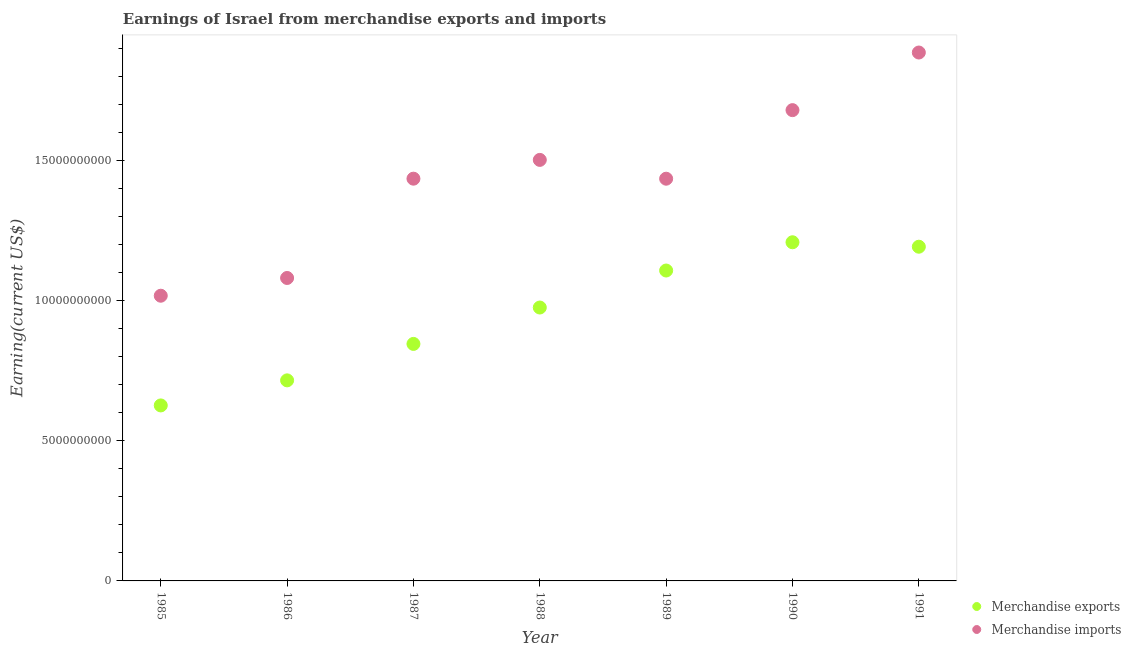What is the earnings from merchandise imports in 1986?
Keep it short and to the point. 1.08e+1. Across all years, what is the maximum earnings from merchandise exports?
Your answer should be very brief. 1.21e+1. Across all years, what is the minimum earnings from merchandise imports?
Provide a short and direct response. 1.02e+1. In which year was the earnings from merchandise imports maximum?
Your answer should be compact. 1991. In which year was the earnings from merchandise imports minimum?
Offer a very short reply. 1985. What is the total earnings from merchandise exports in the graph?
Offer a terse response. 6.67e+1. What is the difference between the earnings from merchandise imports in 1990 and that in 1991?
Your response must be concise. -2.06e+09. What is the difference between the earnings from merchandise imports in 1987 and the earnings from merchandise exports in 1990?
Make the answer very short. 2.27e+09. What is the average earnings from merchandise imports per year?
Keep it short and to the point. 1.43e+1. In the year 1990, what is the difference between the earnings from merchandise exports and earnings from merchandise imports?
Offer a terse response. -4.71e+09. In how many years, is the earnings from merchandise imports greater than 18000000000 US$?
Give a very brief answer. 1. What is the ratio of the earnings from merchandise imports in 1990 to that in 1991?
Your response must be concise. 0.89. What is the difference between the highest and the second highest earnings from merchandise imports?
Your answer should be compact. 2.06e+09. What is the difference between the highest and the lowest earnings from merchandise imports?
Ensure brevity in your answer.  8.68e+09. In how many years, is the earnings from merchandise exports greater than the average earnings from merchandise exports taken over all years?
Offer a very short reply. 4. Is the earnings from merchandise imports strictly greater than the earnings from merchandise exports over the years?
Offer a very short reply. Yes. Are the values on the major ticks of Y-axis written in scientific E-notation?
Ensure brevity in your answer.  No. How many legend labels are there?
Give a very brief answer. 2. How are the legend labels stacked?
Make the answer very short. Vertical. What is the title of the graph?
Keep it short and to the point. Earnings of Israel from merchandise exports and imports. Does "GDP per capita" appear as one of the legend labels in the graph?
Offer a very short reply. No. What is the label or title of the X-axis?
Provide a short and direct response. Year. What is the label or title of the Y-axis?
Give a very brief answer. Earning(current US$). What is the Earning(current US$) of Merchandise exports in 1985?
Offer a very short reply. 6.26e+09. What is the Earning(current US$) in Merchandise imports in 1985?
Your response must be concise. 1.02e+1. What is the Earning(current US$) of Merchandise exports in 1986?
Your response must be concise. 7.15e+09. What is the Earning(current US$) of Merchandise imports in 1986?
Your answer should be very brief. 1.08e+1. What is the Earning(current US$) in Merchandise exports in 1987?
Keep it short and to the point. 8.45e+09. What is the Earning(current US$) of Merchandise imports in 1987?
Provide a succinct answer. 1.43e+1. What is the Earning(current US$) in Merchandise exports in 1988?
Your response must be concise. 9.75e+09. What is the Earning(current US$) in Merchandise imports in 1988?
Provide a short and direct response. 1.50e+1. What is the Earning(current US$) of Merchandise exports in 1989?
Give a very brief answer. 1.11e+1. What is the Earning(current US$) in Merchandise imports in 1989?
Your answer should be compact. 1.43e+1. What is the Earning(current US$) of Merchandise exports in 1990?
Offer a terse response. 1.21e+1. What is the Earning(current US$) of Merchandise imports in 1990?
Give a very brief answer. 1.68e+1. What is the Earning(current US$) of Merchandise exports in 1991?
Make the answer very short. 1.19e+1. What is the Earning(current US$) in Merchandise imports in 1991?
Your answer should be compact. 1.88e+1. Across all years, what is the maximum Earning(current US$) of Merchandise exports?
Make the answer very short. 1.21e+1. Across all years, what is the maximum Earning(current US$) in Merchandise imports?
Your response must be concise. 1.88e+1. Across all years, what is the minimum Earning(current US$) of Merchandise exports?
Provide a succinct answer. 6.26e+09. Across all years, what is the minimum Earning(current US$) in Merchandise imports?
Offer a very short reply. 1.02e+1. What is the total Earning(current US$) in Merchandise exports in the graph?
Your response must be concise. 6.67e+1. What is the total Earning(current US$) in Merchandise imports in the graph?
Give a very brief answer. 1.00e+11. What is the difference between the Earning(current US$) in Merchandise exports in 1985 and that in 1986?
Provide a short and direct response. -8.94e+08. What is the difference between the Earning(current US$) in Merchandise imports in 1985 and that in 1986?
Ensure brevity in your answer.  -6.33e+08. What is the difference between the Earning(current US$) in Merchandise exports in 1985 and that in 1987?
Offer a very short reply. -2.19e+09. What is the difference between the Earning(current US$) in Merchandise imports in 1985 and that in 1987?
Offer a very short reply. -4.18e+09. What is the difference between the Earning(current US$) of Merchandise exports in 1985 and that in 1988?
Your response must be concise. -3.49e+09. What is the difference between the Earning(current US$) of Merchandise imports in 1985 and that in 1988?
Provide a short and direct response. -4.84e+09. What is the difference between the Earning(current US$) in Merchandise exports in 1985 and that in 1989?
Offer a very short reply. -4.81e+09. What is the difference between the Earning(current US$) in Merchandise imports in 1985 and that in 1989?
Your answer should be compact. -4.17e+09. What is the difference between the Earning(current US$) of Merchandise exports in 1985 and that in 1990?
Give a very brief answer. -5.82e+09. What is the difference between the Earning(current US$) of Merchandise imports in 1985 and that in 1990?
Offer a very short reply. -6.62e+09. What is the difference between the Earning(current US$) of Merchandise exports in 1985 and that in 1991?
Your response must be concise. -5.66e+09. What is the difference between the Earning(current US$) of Merchandise imports in 1985 and that in 1991?
Keep it short and to the point. -8.68e+09. What is the difference between the Earning(current US$) of Merchandise exports in 1986 and that in 1987?
Your answer should be very brief. -1.30e+09. What is the difference between the Earning(current US$) of Merchandise imports in 1986 and that in 1987?
Ensure brevity in your answer.  -3.54e+09. What is the difference between the Earning(current US$) in Merchandise exports in 1986 and that in 1988?
Make the answer very short. -2.60e+09. What is the difference between the Earning(current US$) of Merchandise imports in 1986 and that in 1988?
Provide a succinct answer. -4.21e+09. What is the difference between the Earning(current US$) of Merchandise exports in 1986 and that in 1989?
Keep it short and to the point. -3.92e+09. What is the difference between the Earning(current US$) in Merchandise imports in 1986 and that in 1989?
Keep it short and to the point. -3.54e+09. What is the difference between the Earning(current US$) in Merchandise exports in 1986 and that in 1990?
Keep it short and to the point. -4.93e+09. What is the difference between the Earning(current US$) of Merchandise imports in 1986 and that in 1990?
Provide a succinct answer. -5.99e+09. What is the difference between the Earning(current US$) in Merchandise exports in 1986 and that in 1991?
Make the answer very short. -4.77e+09. What is the difference between the Earning(current US$) of Merchandise imports in 1986 and that in 1991?
Your response must be concise. -8.04e+09. What is the difference between the Earning(current US$) of Merchandise exports in 1987 and that in 1988?
Provide a succinct answer. -1.30e+09. What is the difference between the Earning(current US$) of Merchandise imports in 1987 and that in 1988?
Offer a terse response. -6.70e+08. What is the difference between the Earning(current US$) in Merchandise exports in 1987 and that in 1989?
Your response must be concise. -2.62e+09. What is the difference between the Earning(current US$) in Merchandise exports in 1987 and that in 1990?
Provide a succinct answer. -3.63e+09. What is the difference between the Earning(current US$) in Merchandise imports in 1987 and that in 1990?
Offer a very short reply. -2.44e+09. What is the difference between the Earning(current US$) of Merchandise exports in 1987 and that in 1991?
Provide a short and direct response. -3.47e+09. What is the difference between the Earning(current US$) in Merchandise imports in 1987 and that in 1991?
Provide a short and direct response. -4.50e+09. What is the difference between the Earning(current US$) in Merchandise exports in 1988 and that in 1989?
Your answer should be very brief. -1.32e+09. What is the difference between the Earning(current US$) of Merchandise imports in 1988 and that in 1989?
Give a very brief answer. 6.71e+08. What is the difference between the Earning(current US$) of Merchandise exports in 1988 and that in 1990?
Your response must be concise. -2.33e+09. What is the difference between the Earning(current US$) of Merchandise imports in 1988 and that in 1990?
Ensure brevity in your answer.  -1.78e+09. What is the difference between the Earning(current US$) of Merchandise exports in 1988 and that in 1991?
Your response must be concise. -2.17e+09. What is the difference between the Earning(current US$) in Merchandise imports in 1988 and that in 1991?
Offer a terse response. -3.83e+09. What is the difference between the Earning(current US$) in Merchandise exports in 1989 and that in 1990?
Keep it short and to the point. -1.01e+09. What is the difference between the Earning(current US$) in Merchandise imports in 1989 and that in 1990?
Provide a succinct answer. -2.45e+09. What is the difference between the Earning(current US$) of Merchandise exports in 1989 and that in 1991?
Give a very brief answer. -8.49e+08. What is the difference between the Earning(current US$) of Merchandise imports in 1989 and that in 1991?
Keep it short and to the point. -4.50e+09. What is the difference between the Earning(current US$) of Merchandise exports in 1990 and that in 1991?
Keep it short and to the point. 1.59e+08. What is the difference between the Earning(current US$) of Merchandise imports in 1990 and that in 1991?
Your answer should be very brief. -2.06e+09. What is the difference between the Earning(current US$) in Merchandise exports in 1985 and the Earning(current US$) in Merchandise imports in 1986?
Give a very brief answer. -4.55e+09. What is the difference between the Earning(current US$) of Merchandise exports in 1985 and the Earning(current US$) of Merchandise imports in 1987?
Offer a very short reply. -8.09e+09. What is the difference between the Earning(current US$) in Merchandise exports in 1985 and the Earning(current US$) in Merchandise imports in 1988?
Keep it short and to the point. -8.76e+09. What is the difference between the Earning(current US$) in Merchandise exports in 1985 and the Earning(current US$) in Merchandise imports in 1989?
Give a very brief answer. -8.09e+09. What is the difference between the Earning(current US$) in Merchandise exports in 1985 and the Earning(current US$) in Merchandise imports in 1990?
Give a very brief answer. -1.05e+1. What is the difference between the Earning(current US$) in Merchandise exports in 1985 and the Earning(current US$) in Merchandise imports in 1991?
Your answer should be very brief. -1.26e+1. What is the difference between the Earning(current US$) of Merchandise exports in 1986 and the Earning(current US$) of Merchandise imports in 1987?
Provide a succinct answer. -7.19e+09. What is the difference between the Earning(current US$) in Merchandise exports in 1986 and the Earning(current US$) in Merchandise imports in 1988?
Give a very brief answer. -7.86e+09. What is the difference between the Earning(current US$) of Merchandise exports in 1986 and the Earning(current US$) of Merchandise imports in 1989?
Your response must be concise. -7.19e+09. What is the difference between the Earning(current US$) of Merchandise exports in 1986 and the Earning(current US$) of Merchandise imports in 1990?
Your response must be concise. -9.64e+09. What is the difference between the Earning(current US$) of Merchandise exports in 1986 and the Earning(current US$) of Merchandise imports in 1991?
Your response must be concise. -1.17e+1. What is the difference between the Earning(current US$) of Merchandise exports in 1987 and the Earning(current US$) of Merchandise imports in 1988?
Offer a terse response. -6.56e+09. What is the difference between the Earning(current US$) of Merchandise exports in 1987 and the Earning(current US$) of Merchandise imports in 1989?
Offer a terse response. -5.89e+09. What is the difference between the Earning(current US$) in Merchandise exports in 1987 and the Earning(current US$) in Merchandise imports in 1990?
Your answer should be very brief. -8.34e+09. What is the difference between the Earning(current US$) of Merchandise exports in 1987 and the Earning(current US$) of Merchandise imports in 1991?
Provide a short and direct response. -1.04e+1. What is the difference between the Earning(current US$) of Merchandise exports in 1988 and the Earning(current US$) of Merchandise imports in 1989?
Provide a succinct answer. -4.60e+09. What is the difference between the Earning(current US$) in Merchandise exports in 1988 and the Earning(current US$) in Merchandise imports in 1990?
Give a very brief answer. -7.04e+09. What is the difference between the Earning(current US$) in Merchandise exports in 1988 and the Earning(current US$) in Merchandise imports in 1991?
Give a very brief answer. -9.10e+09. What is the difference between the Earning(current US$) in Merchandise exports in 1989 and the Earning(current US$) in Merchandise imports in 1990?
Keep it short and to the point. -5.72e+09. What is the difference between the Earning(current US$) in Merchandise exports in 1989 and the Earning(current US$) in Merchandise imports in 1991?
Provide a short and direct response. -7.78e+09. What is the difference between the Earning(current US$) of Merchandise exports in 1990 and the Earning(current US$) of Merchandise imports in 1991?
Make the answer very short. -6.77e+09. What is the average Earning(current US$) of Merchandise exports per year?
Provide a short and direct response. 9.53e+09. What is the average Earning(current US$) of Merchandise imports per year?
Offer a terse response. 1.43e+1. In the year 1985, what is the difference between the Earning(current US$) of Merchandise exports and Earning(current US$) of Merchandise imports?
Your response must be concise. -3.91e+09. In the year 1986, what is the difference between the Earning(current US$) of Merchandise exports and Earning(current US$) of Merchandise imports?
Make the answer very short. -3.65e+09. In the year 1987, what is the difference between the Earning(current US$) of Merchandise exports and Earning(current US$) of Merchandise imports?
Provide a succinct answer. -5.89e+09. In the year 1988, what is the difference between the Earning(current US$) in Merchandise exports and Earning(current US$) in Merchandise imports?
Ensure brevity in your answer.  -5.27e+09. In the year 1989, what is the difference between the Earning(current US$) of Merchandise exports and Earning(current US$) of Merchandise imports?
Make the answer very short. -3.28e+09. In the year 1990, what is the difference between the Earning(current US$) of Merchandise exports and Earning(current US$) of Merchandise imports?
Provide a short and direct response. -4.71e+09. In the year 1991, what is the difference between the Earning(current US$) of Merchandise exports and Earning(current US$) of Merchandise imports?
Your answer should be very brief. -6.93e+09. What is the ratio of the Earning(current US$) of Merchandise exports in 1985 to that in 1986?
Your response must be concise. 0.88. What is the ratio of the Earning(current US$) of Merchandise imports in 1985 to that in 1986?
Your response must be concise. 0.94. What is the ratio of the Earning(current US$) of Merchandise exports in 1985 to that in 1987?
Provide a succinct answer. 0.74. What is the ratio of the Earning(current US$) of Merchandise imports in 1985 to that in 1987?
Provide a succinct answer. 0.71. What is the ratio of the Earning(current US$) of Merchandise exports in 1985 to that in 1988?
Make the answer very short. 0.64. What is the ratio of the Earning(current US$) in Merchandise imports in 1985 to that in 1988?
Make the answer very short. 0.68. What is the ratio of the Earning(current US$) of Merchandise exports in 1985 to that in 1989?
Make the answer very short. 0.57. What is the ratio of the Earning(current US$) in Merchandise imports in 1985 to that in 1989?
Offer a terse response. 0.71. What is the ratio of the Earning(current US$) in Merchandise exports in 1985 to that in 1990?
Keep it short and to the point. 0.52. What is the ratio of the Earning(current US$) in Merchandise imports in 1985 to that in 1990?
Make the answer very short. 0.61. What is the ratio of the Earning(current US$) of Merchandise exports in 1985 to that in 1991?
Give a very brief answer. 0.53. What is the ratio of the Earning(current US$) in Merchandise imports in 1985 to that in 1991?
Your response must be concise. 0.54. What is the ratio of the Earning(current US$) in Merchandise exports in 1986 to that in 1987?
Provide a short and direct response. 0.85. What is the ratio of the Earning(current US$) in Merchandise imports in 1986 to that in 1987?
Your answer should be very brief. 0.75. What is the ratio of the Earning(current US$) of Merchandise exports in 1986 to that in 1988?
Give a very brief answer. 0.73. What is the ratio of the Earning(current US$) of Merchandise imports in 1986 to that in 1988?
Your answer should be very brief. 0.72. What is the ratio of the Earning(current US$) of Merchandise exports in 1986 to that in 1989?
Your answer should be compact. 0.65. What is the ratio of the Earning(current US$) in Merchandise imports in 1986 to that in 1989?
Your answer should be very brief. 0.75. What is the ratio of the Earning(current US$) in Merchandise exports in 1986 to that in 1990?
Keep it short and to the point. 0.59. What is the ratio of the Earning(current US$) of Merchandise imports in 1986 to that in 1990?
Your answer should be very brief. 0.64. What is the ratio of the Earning(current US$) in Merchandise exports in 1986 to that in 1991?
Keep it short and to the point. 0.6. What is the ratio of the Earning(current US$) in Merchandise imports in 1986 to that in 1991?
Ensure brevity in your answer.  0.57. What is the ratio of the Earning(current US$) of Merchandise exports in 1987 to that in 1988?
Make the answer very short. 0.87. What is the ratio of the Earning(current US$) in Merchandise imports in 1987 to that in 1988?
Provide a succinct answer. 0.96. What is the ratio of the Earning(current US$) of Merchandise exports in 1987 to that in 1989?
Offer a terse response. 0.76. What is the ratio of the Earning(current US$) of Merchandise exports in 1987 to that in 1990?
Ensure brevity in your answer.  0.7. What is the ratio of the Earning(current US$) of Merchandise imports in 1987 to that in 1990?
Ensure brevity in your answer.  0.85. What is the ratio of the Earning(current US$) in Merchandise exports in 1987 to that in 1991?
Make the answer very short. 0.71. What is the ratio of the Earning(current US$) in Merchandise imports in 1987 to that in 1991?
Your answer should be compact. 0.76. What is the ratio of the Earning(current US$) in Merchandise exports in 1988 to that in 1989?
Offer a very short reply. 0.88. What is the ratio of the Earning(current US$) of Merchandise imports in 1988 to that in 1989?
Make the answer very short. 1.05. What is the ratio of the Earning(current US$) of Merchandise exports in 1988 to that in 1990?
Offer a terse response. 0.81. What is the ratio of the Earning(current US$) in Merchandise imports in 1988 to that in 1990?
Keep it short and to the point. 0.89. What is the ratio of the Earning(current US$) of Merchandise exports in 1988 to that in 1991?
Your answer should be compact. 0.82. What is the ratio of the Earning(current US$) in Merchandise imports in 1988 to that in 1991?
Keep it short and to the point. 0.8. What is the ratio of the Earning(current US$) in Merchandise exports in 1989 to that in 1990?
Ensure brevity in your answer.  0.92. What is the ratio of the Earning(current US$) in Merchandise imports in 1989 to that in 1990?
Ensure brevity in your answer.  0.85. What is the ratio of the Earning(current US$) in Merchandise exports in 1989 to that in 1991?
Ensure brevity in your answer.  0.93. What is the ratio of the Earning(current US$) of Merchandise imports in 1989 to that in 1991?
Offer a very short reply. 0.76. What is the ratio of the Earning(current US$) of Merchandise exports in 1990 to that in 1991?
Offer a terse response. 1.01. What is the ratio of the Earning(current US$) of Merchandise imports in 1990 to that in 1991?
Offer a terse response. 0.89. What is the difference between the highest and the second highest Earning(current US$) of Merchandise exports?
Offer a very short reply. 1.59e+08. What is the difference between the highest and the second highest Earning(current US$) in Merchandise imports?
Provide a short and direct response. 2.06e+09. What is the difference between the highest and the lowest Earning(current US$) in Merchandise exports?
Make the answer very short. 5.82e+09. What is the difference between the highest and the lowest Earning(current US$) of Merchandise imports?
Your answer should be very brief. 8.68e+09. 